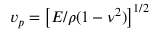Convert formula to latex. <formula><loc_0><loc_0><loc_500><loc_500>v _ { p } = \left [ E / \rho ( 1 - \nu ^ { 2 } ) \right ] ^ { 1 / 2 }</formula> 